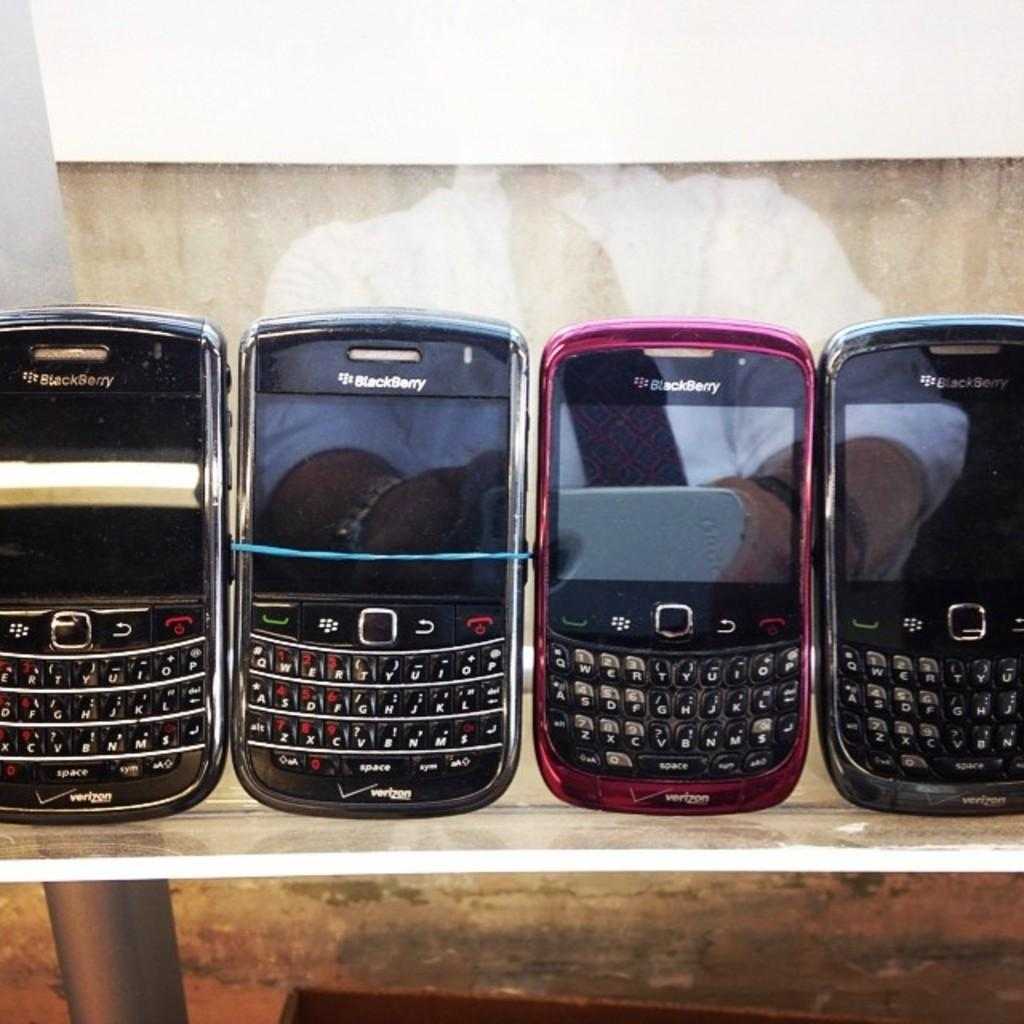<image>
Render a clear and concise summary of the photo. A row of Blackberry phones that say Verizon are on a shelf. 